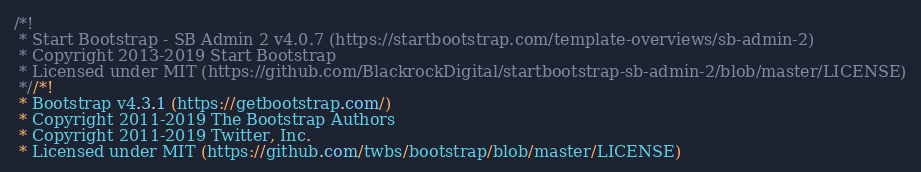<code> <loc_0><loc_0><loc_500><loc_500><_CSS_>/*!
 * Start Bootstrap - SB Admin 2 v4.0.7 (https://startbootstrap.com/template-overviews/sb-admin-2)
 * Copyright 2013-2019 Start Bootstrap
 * Licensed under MIT (https://github.com/BlackrockDigital/startbootstrap-sb-admin-2/blob/master/LICENSE)
 *//*!
 * Bootstrap v4.3.1 (https://getbootstrap.com/)
 * Copyright 2011-2019 The Bootstrap Authors
 * Copyright 2011-2019 Twitter, Inc.
 * Licensed under MIT (https://github.com/twbs/bootstrap/blob/master/LICENSE)</code> 